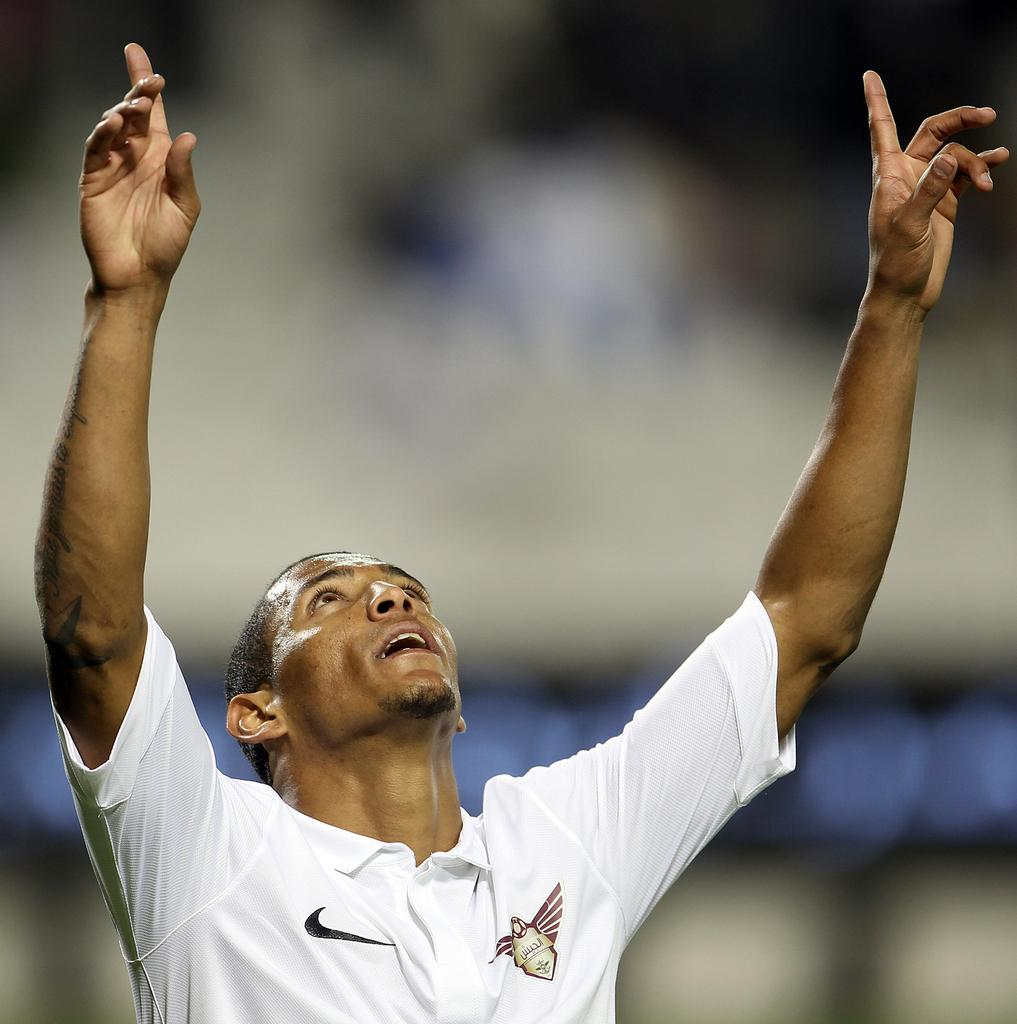What is the main subject in the foreground of the image? There is a person in the foreground of the image. What is the person doing in the image? The person has raised his hands. Can you describe the background of the image? The background of the image is blurred. How many pizzas are visible on the ground in the image? There are no pizzas visible in the image. Is there any dirt or ants present in the image? There is no dirt or ants mentioned or visible in the image. 